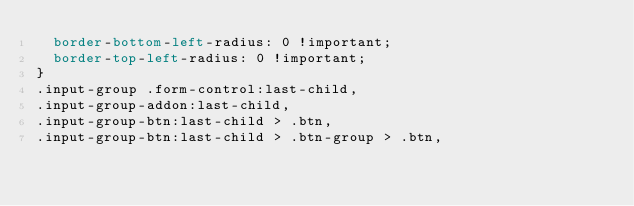Convert code to text. <code><loc_0><loc_0><loc_500><loc_500><_CSS_>  border-bottom-left-radius: 0 !important;
  border-top-left-radius: 0 !important;
}
.input-group .form-control:last-child,
.input-group-addon:last-child,
.input-group-btn:last-child > .btn,
.input-group-btn:last-child > .btn-group > .btn,</code> 